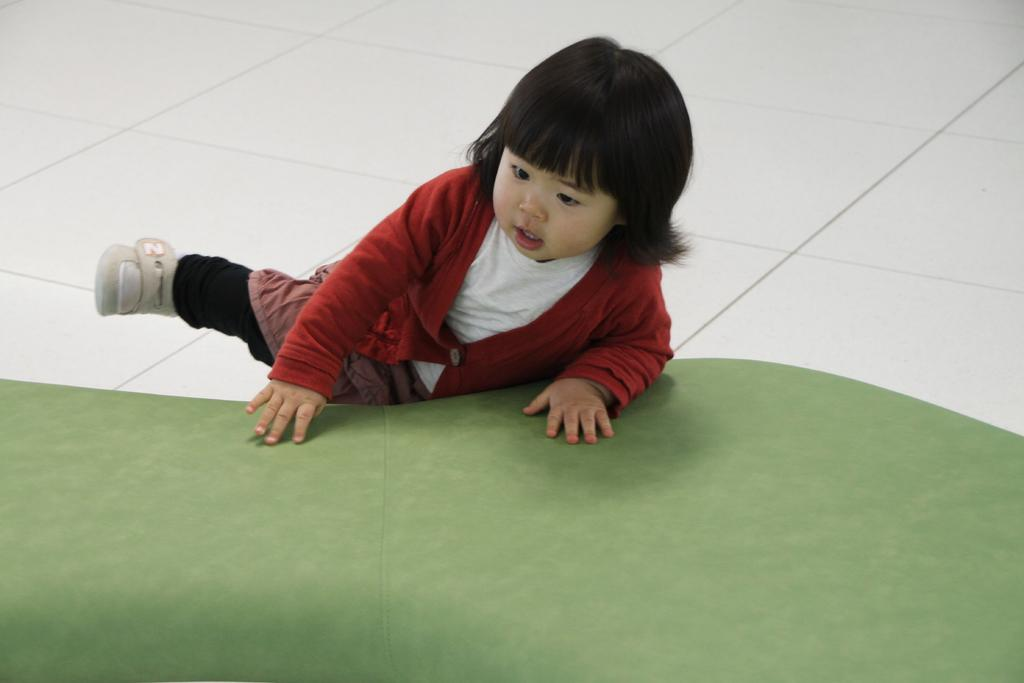What is the main subject of the image? The main subject of the image is a kid. What is the kid standing or sitting on in the image? The kid is on a green surface. Is the kid sleeping on a bed in the image? There is no mention of a bed in the image, and the kid is on a green surface, not a bed. 